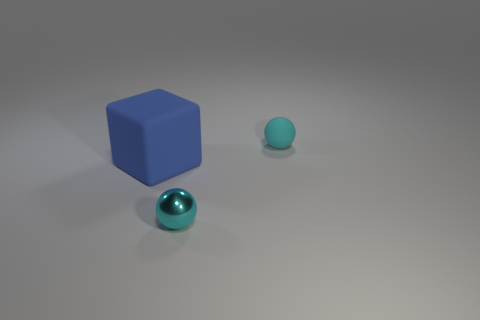Imagine this is a scene from a story. What could be happening here? This could be a moment of quiet discovery in an otherworldly landscape, where each object represents an element of a larger puzzle meant to be solved by an unseen traveler. What might the blue cube symbolize in that story? In our tale, the cube might symbolize structure and stability, a relic anchoring the fabric of this realm. It could be an artifact bestowing order amid the unpredictable terrains explored by the protagonist. 